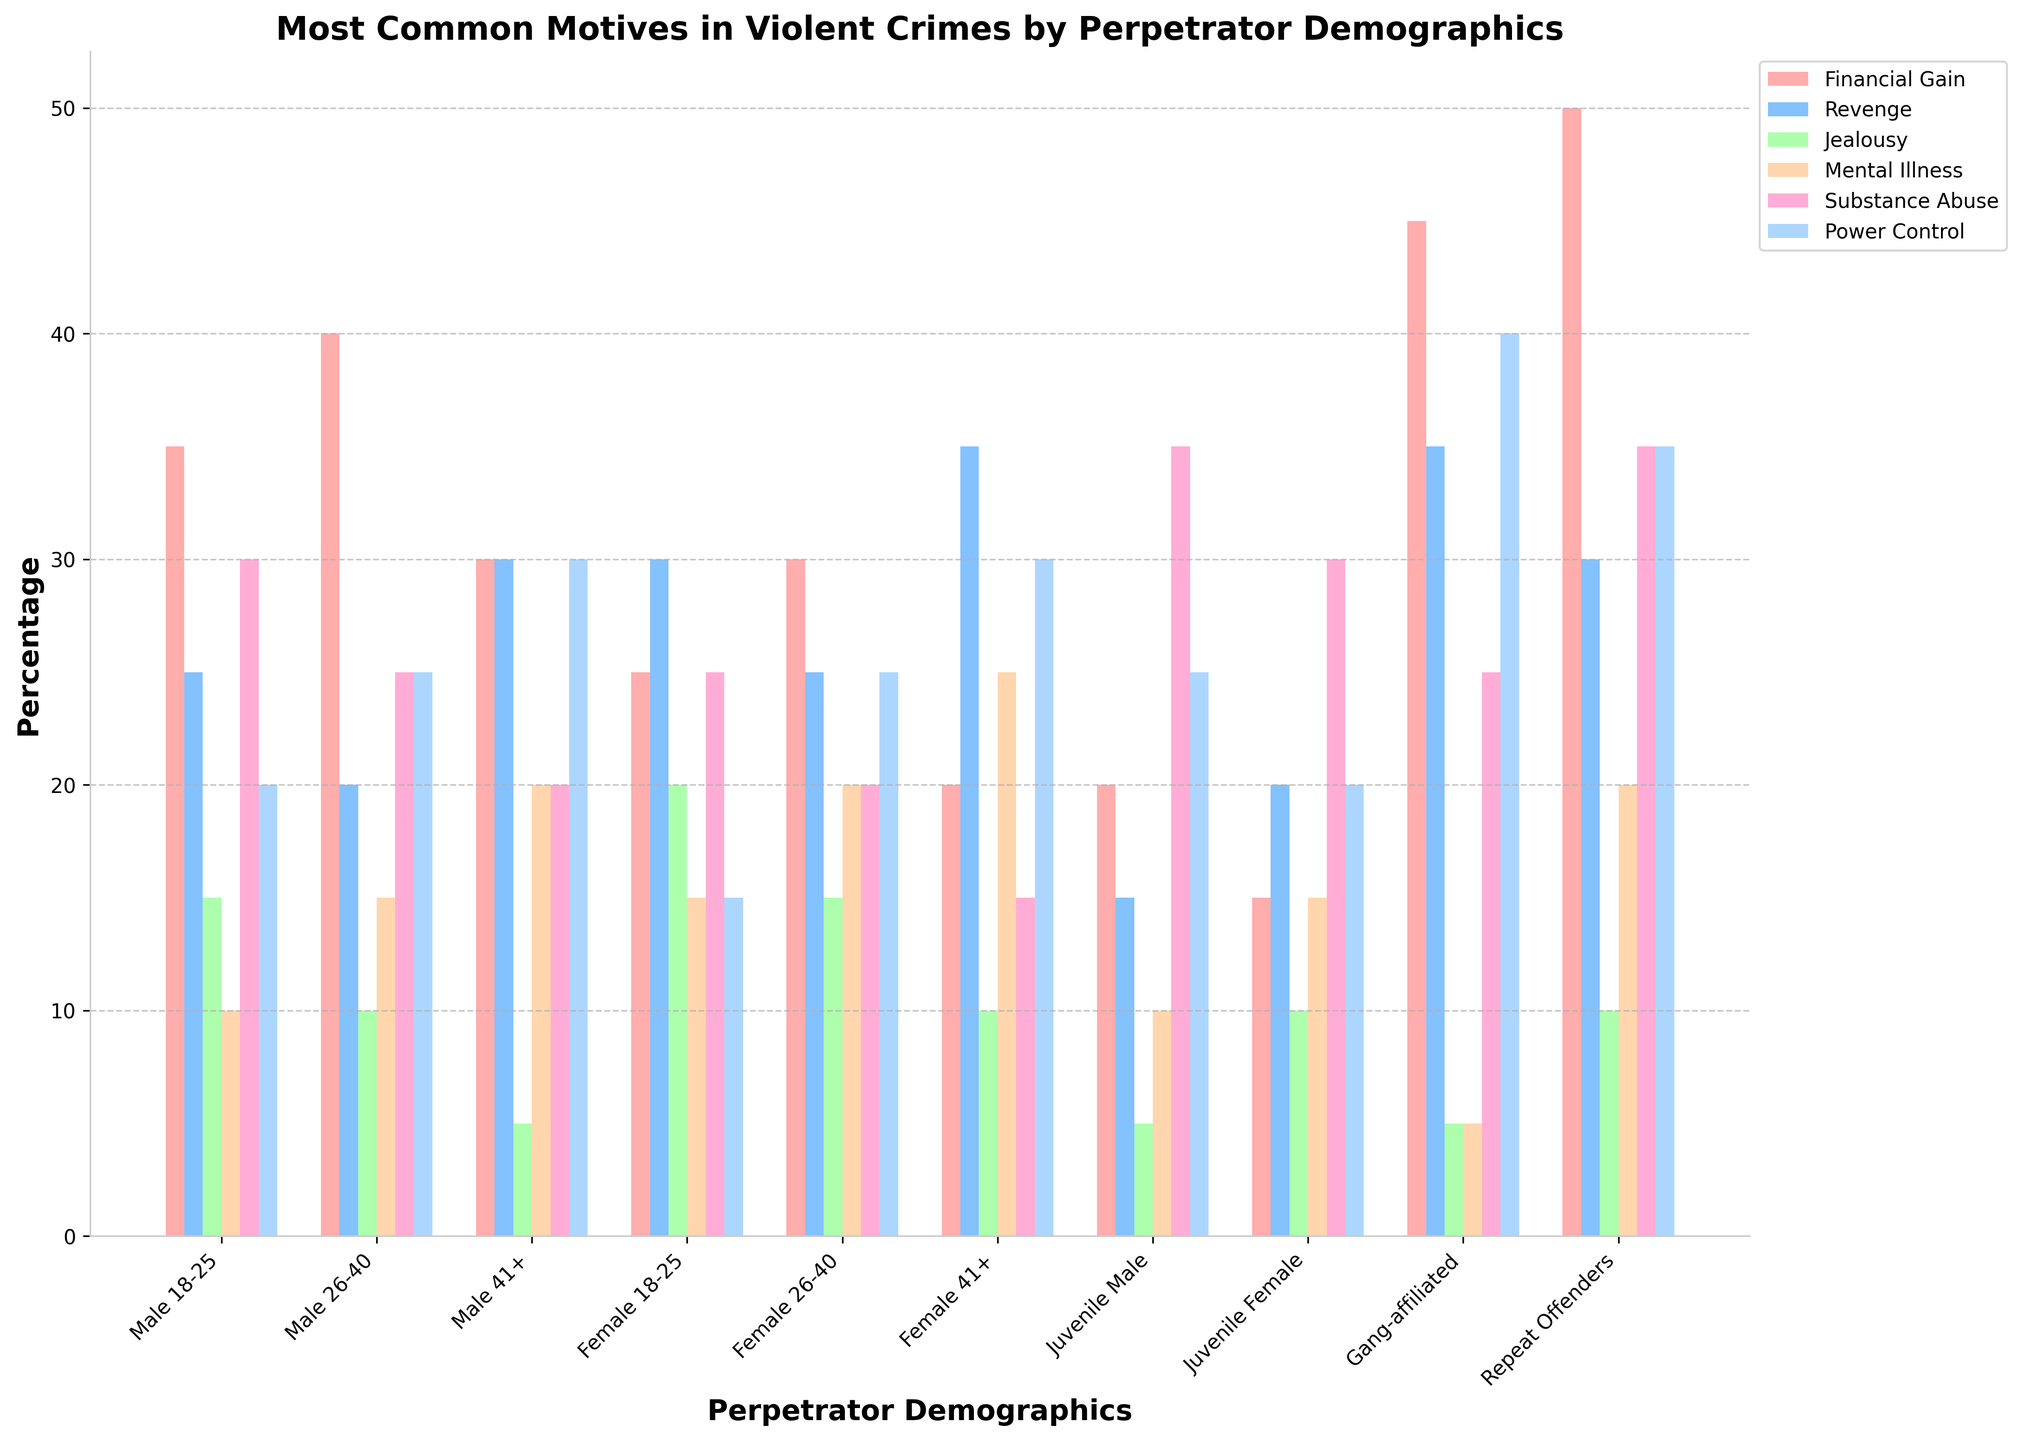Which perpetrator demographic has the highest percentage for financial gain motive? Look at the height of the bars for the financial gain category. The highest bar for financial gain is for Repeat Offenders.
Answer: Repeat Offenders Compare the percentage of mental illness motive for Male 41+ and Female 41+ demographics. Which is higher? Look at the height of the bars for the mental illness category for both demographics. The Male 41+ shows a bar at 20%, while Female 41+ shows a bar at 25%.
Answer: Female 41+ What is the average percentage of revenge motive across all Female demographics (18-25, 26-40, 41+)? Add the percentages for the revenge motive in Female demographics (30 + 25 + 35), then divide by 3. (30 + 25 + 35) / 3 = 30
Answer: 30 What is the total percentage of substance abuse motive for Juvenile demographics (Male and Female)? Add the substance abuse percentages for Juvenile Male and Juvenile Female: 35% + 30% = 65%
Answer: 65 Which motive has the lowest percentage for Gang-affiliated perpetrators? Look at the bars for the Gang-affiliated category, the shortest bar is for mental illness with 5%.
Answer: Mental Illness Is the percentage of power/control motive greater for Male 26-40 than for Male 18-25? Compare the heights of the power/control bars for Male 26-40 and Male 18-25. Male 26-40 has 25%, whereas Male 18-25 has 20%.
Answer: Yes What are the top two motives for Female 26-40 perpetrators in terms of percentage? Look at the heights of the bars for Female 26-40. The highest bars are for financial gain and power/control, both at 25%.
Answer: Financial Gain, Power Control How much greater is the financial gain motive for Repeat Offenders compared to Juvenile Male offenders? Subtract the financial gain percentage for Juvenile Male from Repeat Offenders: 50% - 20% = 30%
Answer: 30 Which perpetrator demographic has the highest overall percentage for any single motive, and what is the motive and percentage? Look at the tallest bar in the entire figure. The tallest bar is financial gain for Repeat Offenders at 50%.
Answer: Repeat Offenders, Financial Gain, 50% What is the difference in the jealousy motive percentages between Male 18-25 and Juvenile Male perpetrators? Subtract the jealousy percentage for Juvenile Male from Male 18-25: 15% - 5% = 10%
Answer: 10 